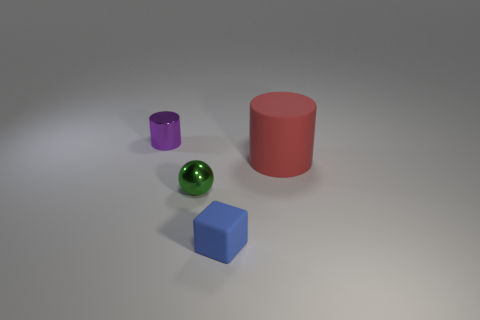How many things are either rubber things that are left of the big matte cylinder or purple metal cylinders?
Provide a succinct answer. 2. Do the sphere and the object that is on the right side of the blue matte object have the same material?
Keep it short and to the point. No. Is there a big red cylinder made of the same material as the tiny blue cube?
Offer a very short reply. Yes. What number of things are matte things on the left side of the large red matte cylinder or cylinders left of the small blue thing?
Keep it short and to the point. 2. There is a big thing; is it the same shape as the thing left of the small green sphere?
Give a very brief answer. Yes. How many other objects are there of the same shape as the blue rubber thing?
Your response must be concise. 0. How many objects are either big matte objects or tiny green things?
Provide a succinct answer. 2. Is the color of the tiny block the same as the metallic cylinder?
Your response must be concise. No. Is there any other thing that has the same size as the green metallic ball?
Offer a terse response. Yes. What shape is the thing that is behind the cylinder on the right side of the green thing?
Provide a short and direct response. Cylinder. 